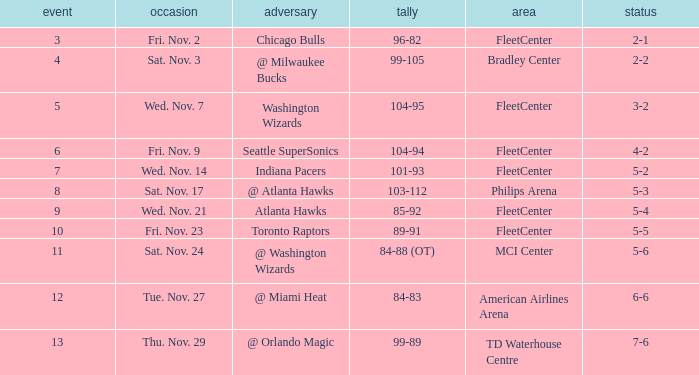Would you mind parsing the complete table? {'header': ['event', 'occasion', 'adversary', 'tally', 'area', 'status'], 'rows': [['3', 'Fri. Nov. 2', 'Chicago Bulls', '96-82', 'FleetCenter', '2-1'], ['4', 'Sat. Nov. 3', '@ Milwaukee Bucks', '99-105', 'Bradley Center', '2-2'], ['5', 'Wed. Nov. 7', 'Washington Wizards', '104-95', 'FleetCenter', '3-2'], ['6', 'Fri. Nov. 9', 'Seattle SuperSonics', '104-94', 'FleetCenter', '4-2'], ['7', 'Wed. Nov. 14', 'Indiana Pacers', '101-93', 'FleetCenter', '5-2'], ['8', 'Sat. Nov. 17', '@ Atlanta Hawks', '103-112', 'Philips Arena', '5-3'], ['9', 'Wed. Nov. 21', 'Atlanta Hawks', '85-92', 'FleetCenter', '5-4'], ['10', 'Fri. Nov. 23', 'Toronto Raptors', '89-91', 'FleetCenter', '5-5'], ['11', 'Sat. Nov. 24', '@ Washington Wizards', '84-88 (OT)', 'MCI Center', '5-6'], ['12', 'Tue. Nov. 27', '@ Miami Heat', '84-83', 'American Airlines Arena', '6-6'], ['13', 'Thu. Nov. 29', '@ Orlando Magic', '99-89', 'TD Waterhouse Centre', '7-6']]} How many games have a score of 85-92? 1.0. 